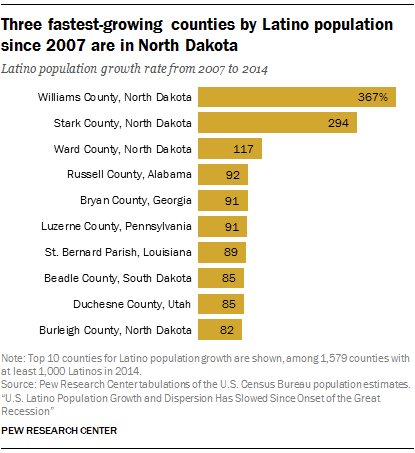Draw attention to some important aspects in this diagram. There are 10 categories in the chart. The sum of the two largest bars is 661. 